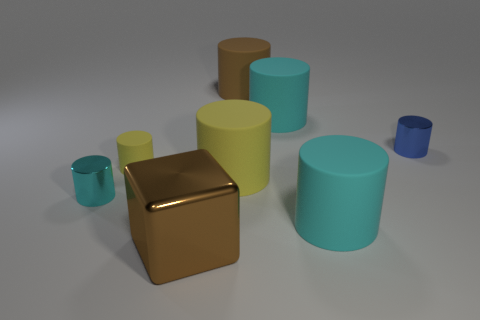Subtract all cyan spheres. How many cyan cylinders are left? 3 Subtract all yellow cylinders. How many cylinders are left? 5 Subtract all blue metal cylinders. How many cylinders are left? 6 Subtract 2 cylinders. How many cylinders are left? 5 Subtract all brown cylinders. Subtract all gray balls. How many cylinders are left? 6 Add 1 small cyan cylinders. How many objects exist? 9 Subtract all cylinders. How many objects are left? 1 Subtract all cyan cylinders. Subtract all large cyan objects. How many objects are left? 3 Add 8 big cyan cylinders. How many big cyan cylinders are left? 10 Add 1 tiny yellow rubber cylinders. How many tiny yellow rubber cylinders exist? 2 